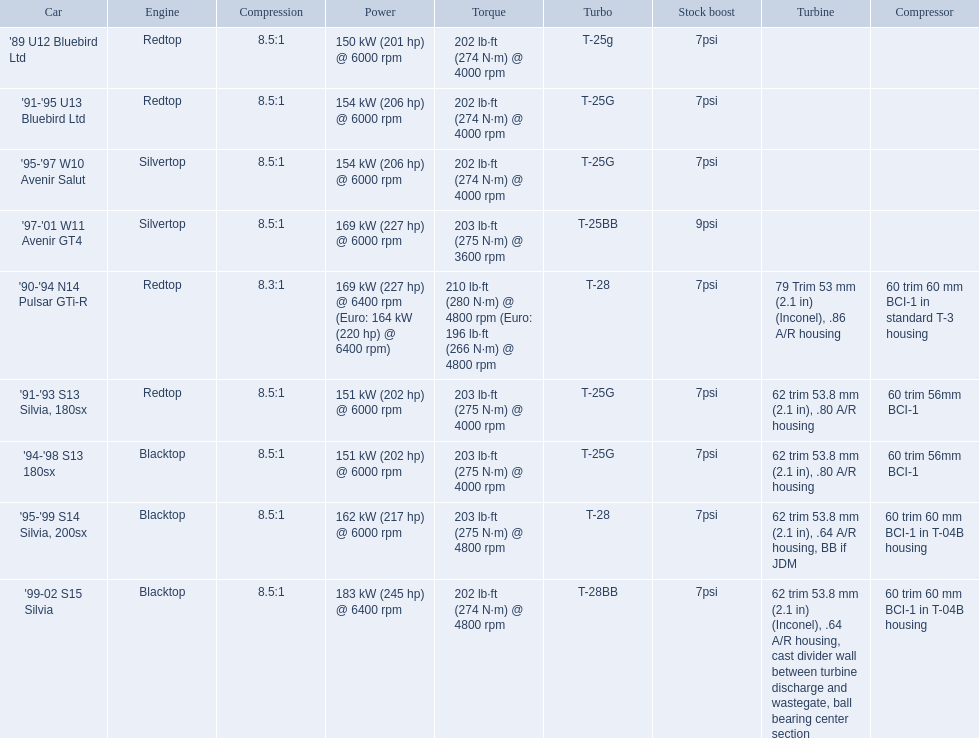Would you be able to parse every entry in this table? {'header': ['Car', 'Engine', 'Compression', 'Power', 'Torque', 'Turbo', 'Stock boost', 'Turbine', 'Compressor'], 'rows': [["'89 U12 Bluebird Ltd", 'Redtop', '8.5:1', '150\xa0kW (201\xa0hp) @ 6000 rpm', '202\xa0lb·ft (274\xa0N·m) @ 4000 rpm', 'T-25g', '7psi', '', ''], ["'91-'95 U13 Bluebird Ltd", 'Redtop', '8.5:1', '154\xa0kW (206\xa0hp) @ 6000 rpm', '202\xa0lb·ft (274\xa0N·m) @ 4000 rpm', 'T-25G', '7psi', '', ''], ["'95-'97 W10 Avenir Salut", 'Silvertop', '8.5:1', '154\xa0kW (206\xa0hp) @ 6000 rpm', '202\xa0lb·ft (274\xa0N·m) @ 4000 rpm', 'T-25G', '7psi', '', ''], ["'97-'01 W11 Avenir GT4", 'Silvertop', '8.5:1', '169\xa0kW (227\xa0hp) @ 6000 rpm', '203\xa0lb·ft (275\xa0N·m) @ 3600 rpm', 'T-25BB', '9psi', '', ''], ["'90-'94 N14 Pulsar GTi-R", 'Redtop', '8.3:1', '169\xa0kW (227\xa0hp) @ 6400 rpm (Euro: 164\xa0kW (220\xa0hp) @ 6400 rpm)', '210\xa0lb·ft (280\xa0N·m) @ 4800 rpm (Euro: 196\xa0lb·ft (266\xa0N·m) @ 4800 rpm', 'T-28', '7psi', '79 Trim 53\xa0mm (2.1\xa0in) (Inconel), .86 A/R housing', '60 trim 60\xa0mm BCI-1 in standard T-3 housing'], ["'91-'93 S13 Silvia, 180sx", 'Redtop', '8.5:1', '151\xa0kW (202\xa0hp) @ 6000 rpm', '203\xa0lb·ft (275\xa0N·m) @ 4000 rpm', 'T-25G', '7psi', '62 trim 53.8\xa0mm (2.1\xa0in), .80 A/R housing', '60 trim 56mm BCI-1'], ["'94-'98 S13 180sx", 'Blacktop', '8.5:1', '151\xa0kW (202\xa0hp) @ 6000 rpm', '203\xa0lb·ft (275\xa0N·m) @ 4000 rpm', 'T-25G', '7psi', '62 trim 53.8\xa0mm (2.1\xa0in), .80 A/R housing', '60 trim 56mm BCI-1'], ["'95-'99 S14 Silvia, 200sx", 'Blacktop', '8.5:1', '162\xa0kW (217\xa0hp) @ 6000 rpm', '203\xa0lb·ft (275\xa0N·m) @ 4800 rpm', 'T-28', '7psi', '62 trim 53.8\xa0mm (2.1\xa0in), .64 A/R housing, BB if JDM', '60 trim 60\xa0mm BCI-1 in T-04B housing'], ["'99-02 S15 Silvia", 'Blacktop', '8.5:1', '183\xa0kW (245\xa0hp) @ 6400 rpm', '202\xa0lb·ft (274\xa0N·m) @ 4800 rpm', 'T-28BB', '7psi', '62 trim 53.8\xa0mm (2.1\xa0in) (Inconel), .64 A/R housing, cast divider wall between turbine discharge and wastegate, ball bearing center section', '60 trim 60\xa0mm BCI-1 in T-04B housing']]} What are the noted hp of the cars? 150 kW (201 hp) @ 6000 rpm, 154 kW (206 hp) @ 6000 rpm, 154 kW (206 hp) @ 6000 rpm, 169 kW (227 hp) @ 6000 rpm, 169 kW (227 hp) @ 6400 rpm (Euro: 164 kW (220 hp) @ 6400 rpm), 151 kW (202 hp) @ 6000 rpm, 151 kW (202 hp) @ 6000 rpm, 162 kW (217 hp) @ 6000 rpm, 183 kW (245 hp) @ 6400 rpm. Which is the single car with in excess of 230 hp? '99-02 S15 Silvia. 